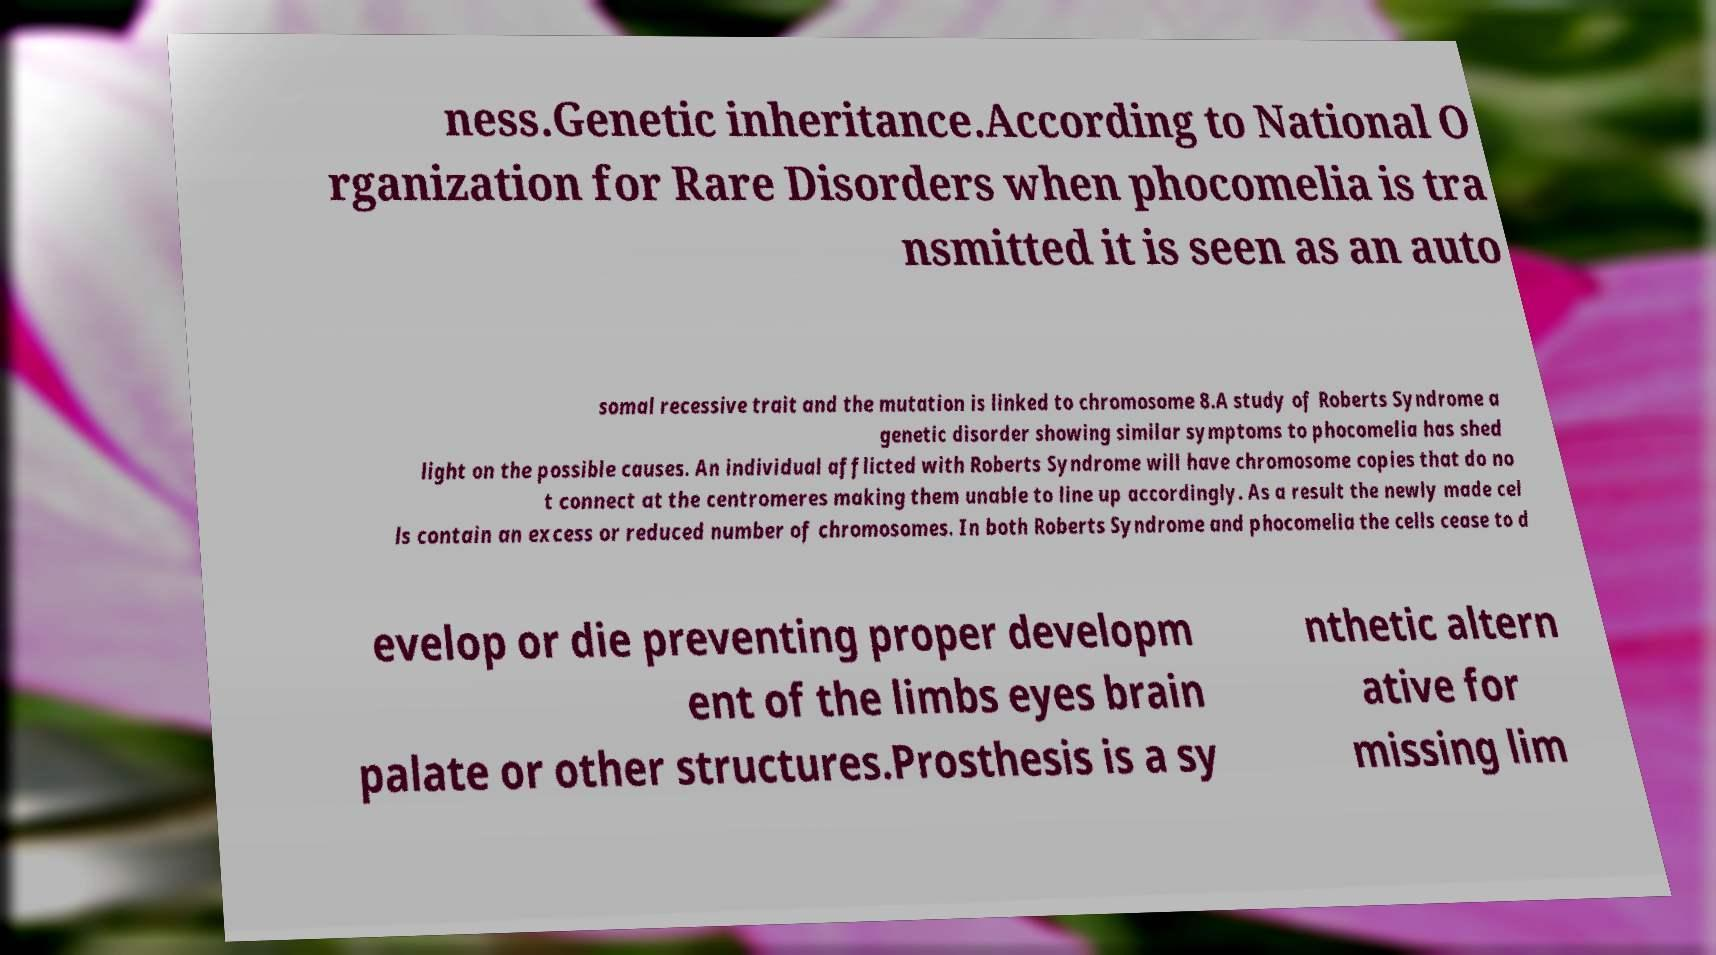Please identify and transcribe the text found in this image. ness.Genetic inheritance.According to National O rganization for Rare Disorders when phocomelia is tra nsmitted it is seen as an auto somal recessive trait and the mutation is linked to chromosome 8.A study of Roberts Syndrome a genetic disorder showing similar symptoms to phocomelia has shed light on the possible causes. An individual afflicted with Roberts Syndrome will have chromosome copies that do no t connect at the centromeres making them unable to line up accordingly. As a result the newly made cel ls contain an excess or reduced number of chromosomes. In both Roberts Syndrome and phocomelia the cells cease to d evelop or die preventing proper developm ent of the limbs eyes brain palate or other structures.Prosthesis is a sy nthetic altern ative for missing lim 